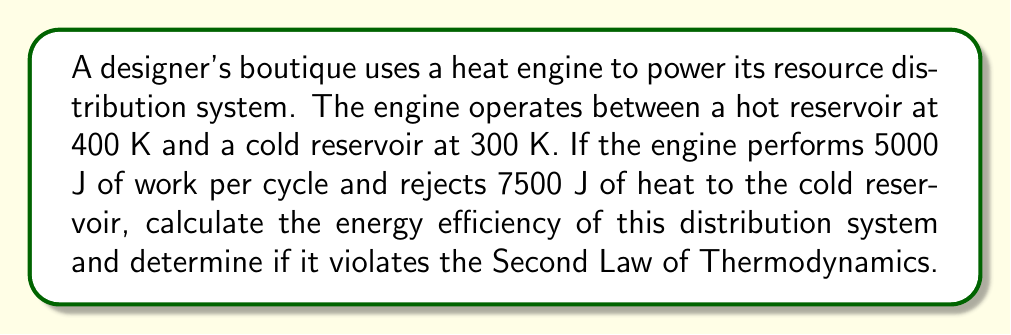Teach me how to tackle this problem. Let's approach this step-by-step using thermodynamics principles:

1) First, let's define the variables:
   $T_H = 400$ K (hot reservoir temperature)
   $T_C = 300$ K (cold reservoir temperature)
   $W = 5000$ J (work done per cycle)
   $Q_C = 7500$ J (heat rejected to cold reservoir)

2) To find the efficiency, we need to know the heat input $Q_H$. We can find this using the First Law of Thermodynamics:
   $Q_H = W + Q_C$
   $Q_H = 5000 + 7500 = 12500$ J

3) The efficiency $\eta$ of a heat engine is defined as:
   $$\eta = \frac{W}{Q_H} = \frac{Q_H - Q_C}{Q_H}$$

4) Plugging in our values:
   $$\eta = \frac{12500 - 7500}{12500} = \frac{5000}{12500} = 0.4 = 40\%$$

5) To check if this violates the Second Law, we need to compare it to the Carnot efficiency, which is the maximum possible efficiency:
   $$\eta_{Carnot} = 1 - \frac{T_C}{T_H} = 1 - \frac{300}{400} = 0.25 = 25\%$$

6) Since our calculated efficiency (40%) is greater than the Carnot efficiency (25%), this system violates the Second Law of Thermodynamics.
Answer: Efficiency: 40%; Violates Second Law 